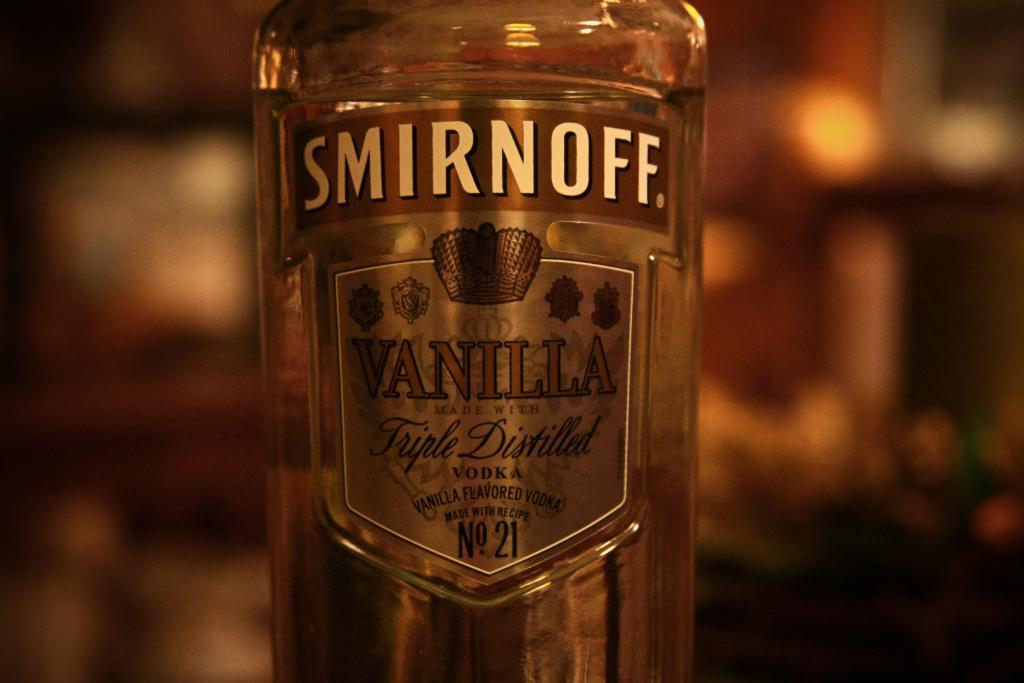Provide a one-sentence caption for the provided image. A bottle of Smirnoff Vanilla is in a dimly lit room. 